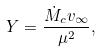Convert formula to latex. <formula><loc_0><loc_0><loc_500><loc_500>Y = \frac { \dot { M } _ { c } v _ { \infty } } { \mu ^ { 2 } } ,</formula> 